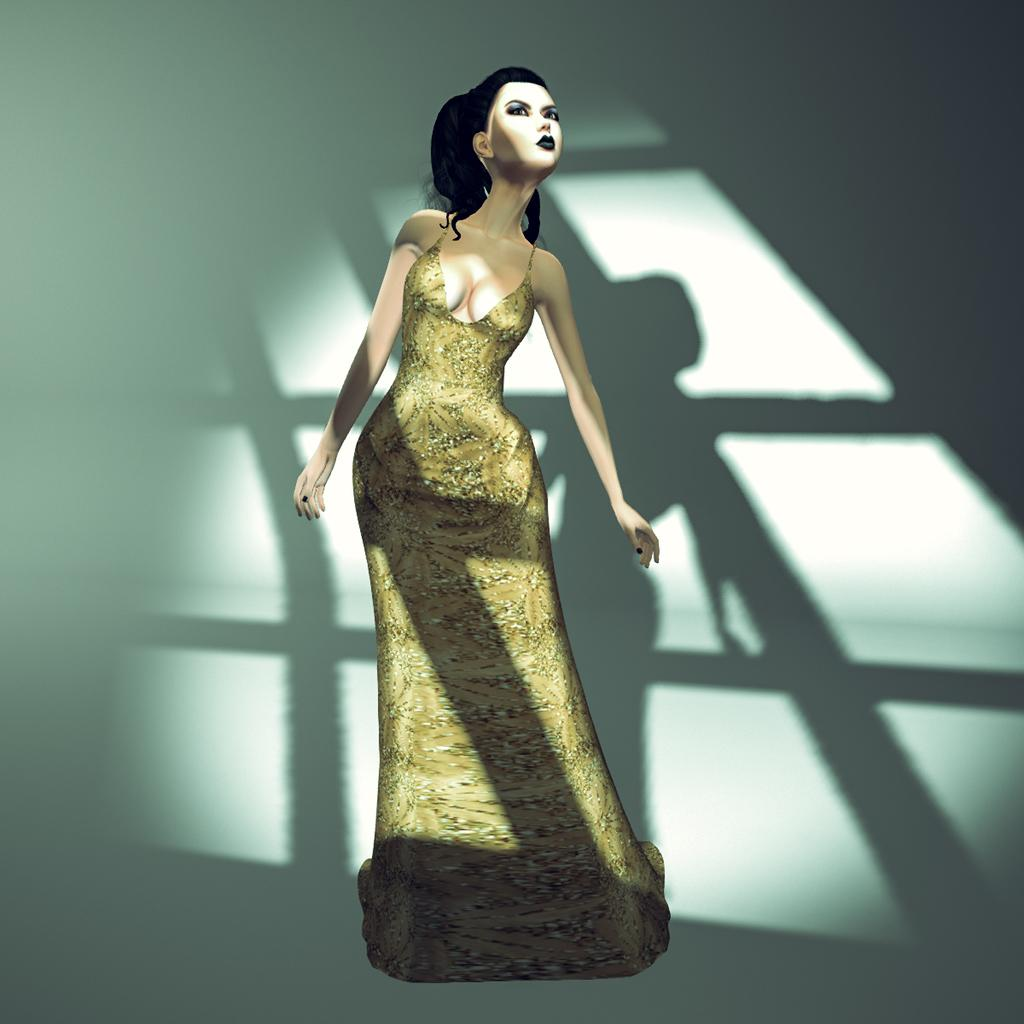What type of image is being described? The image is an animated picture. Can you describe the scene in the image? There is a person standing on the surface in the image. How many legs does the mountain have in the image? There is no mountain present in the image, and therefore no legs can be counted. 